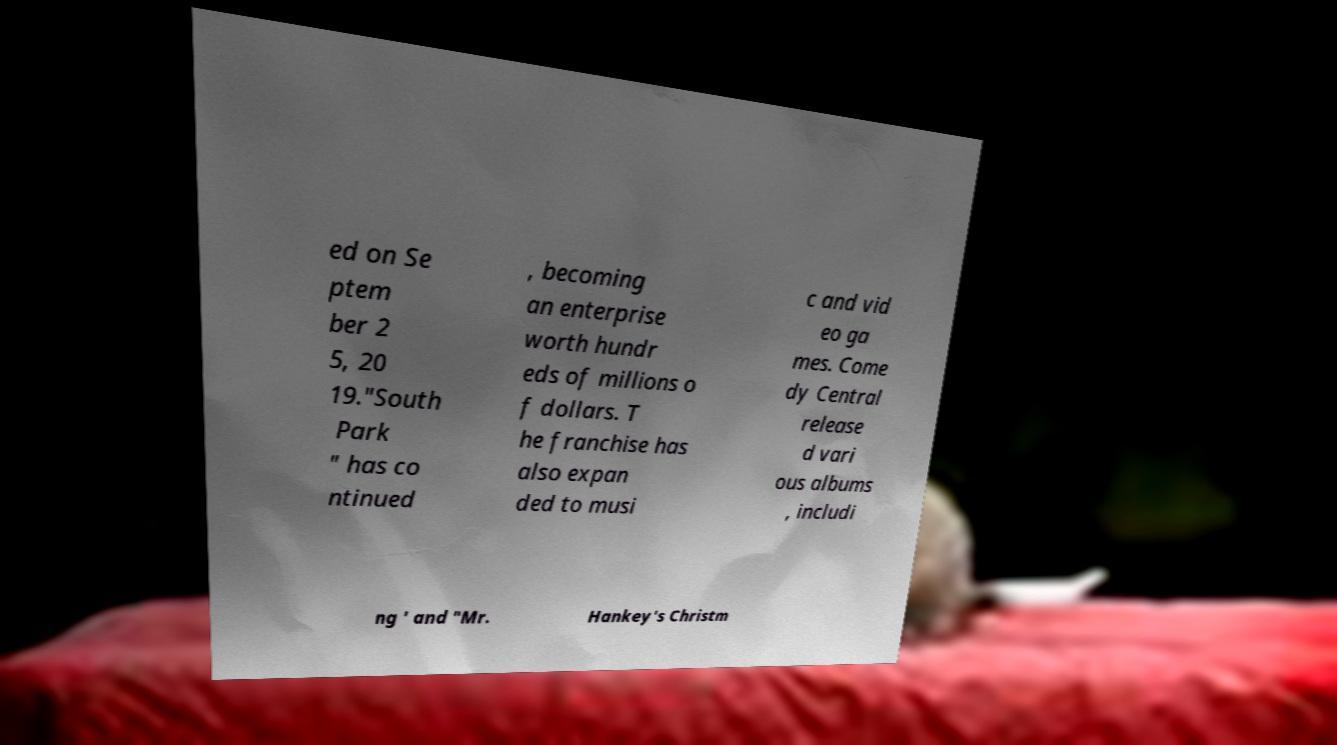Could you assist in decoding the text presented in this image and type it out clearly? ed on Se ptem ber 2 5, 20 19."South Park " has co ntinued , becoming an enterprise worth hundr eds of millions o f dollars. T he franchise has also expan ded to musi c and vid eo ga mes. Come dy Central release d vari ous albums , includi ng ' and "Mr. Hankey's Christm 